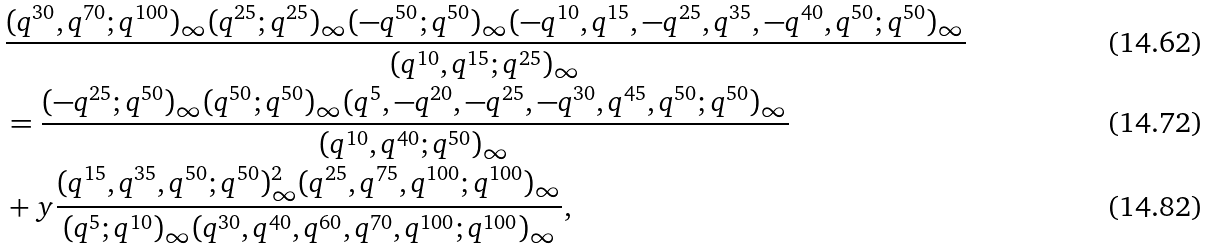Convert formula to latex. <formula><loc_0><loc_0><loc_500><loc_500>& \frac { ( q ^ { 3 0 } , q ^ { 7 0 } ; q ^ { 1 0 0 } ) _ { \infty } ( q ^ { 2 5 } ; q ^ { 2 5 } ) _ { \infty } ( - q ^ { 5 0 } ; q ^ { 5 0 } ) _ { \infty } ( - q ^ { 1 0 } , q ^ { 1 5 } , - q ^ { 2 5 } , q ^ { 3 5 } , - q ^ { 4 0 } , q ^ { 5 0 } ; q ^ { 5 0 } ) _ { \infty } } { ( q ^ { 1 0 } , q ^ { 1 5 } ; q ^ { 2 5 } ) _ { \infty } } \\ & = \frac { ( - q ^ { 2 5 } ; q ^ { 5 0 } ) _ { \infty } ( q ^ { 5 0 } ; q ^ { 5 0 } ) _ { \infty } ( q ^ { 5 } , - q ^ { 2 0 } , - q ^ { 2 5 } , - q ^ { 3 0 } , q ^ { 4 5 } , q ^ { 5 0 } ; q ^ { 5 0 } ) _ { \infty } } { ( q ^ { 1 0 } , q ^ { 4 0 } ; q ^ { 5 0 } ) _ { \infty } } \\ & + y \frac { ( q ^ { 1 5 } , q ^ { 3 5 } , q ^ { 5 0 } ; q ^ { 5 0 } ) _ { \infty } ^ { 2 } ( q ^ { 2 5 } , q ^ { 7 5 } , q ^ { 1 0 0 } ; q ^ { 1 0 0 } ) _ { \infty } } { ( q ^ { 5 } ; q ^ { 1 0 } ) _ { \infty } ( q ^ { 3 0 } , q ^ { 4 0 } , q ^ { 6 0 } , q ^ { 7 0 } , q ^ { 1 0 0 } ; q ^ { 1 0 0 } ) _ { \infty } } ,</formula> 